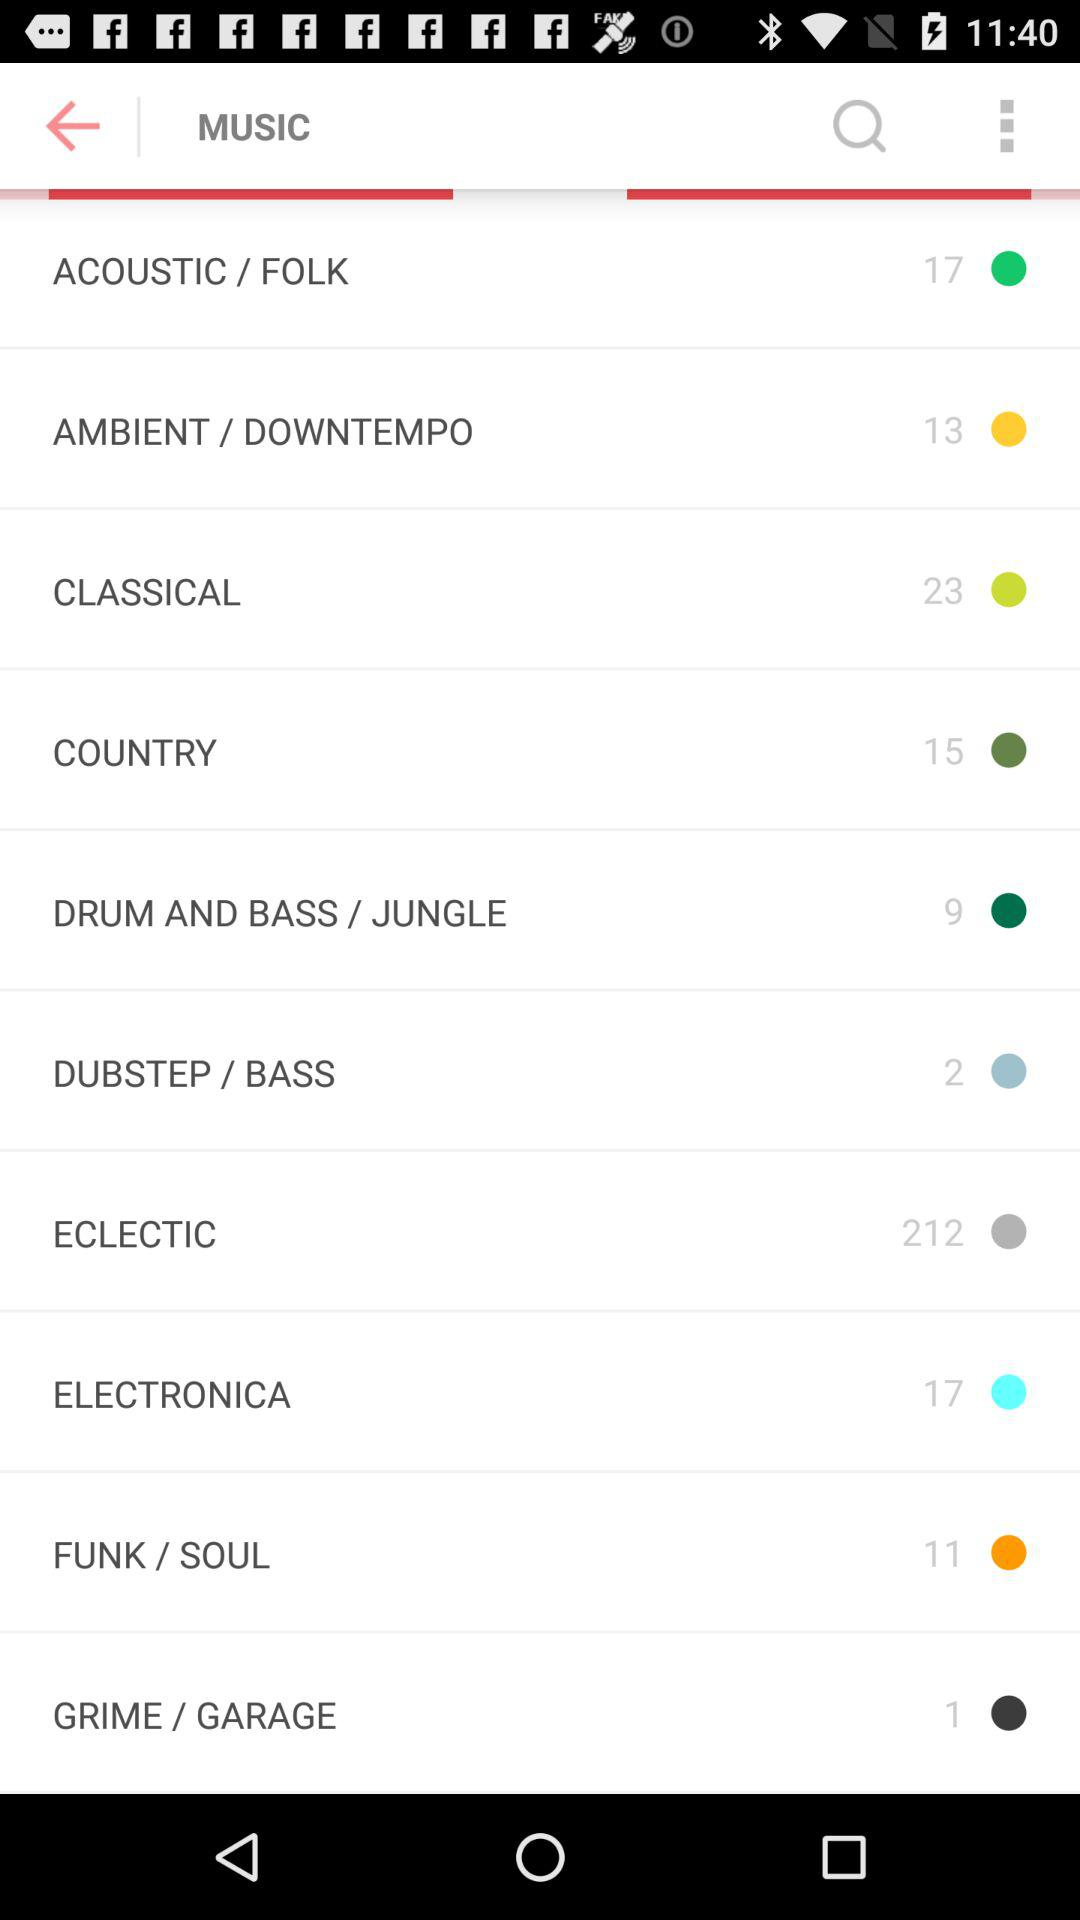How many music genres are there?
Answer the question using a single word or phrase. 10 